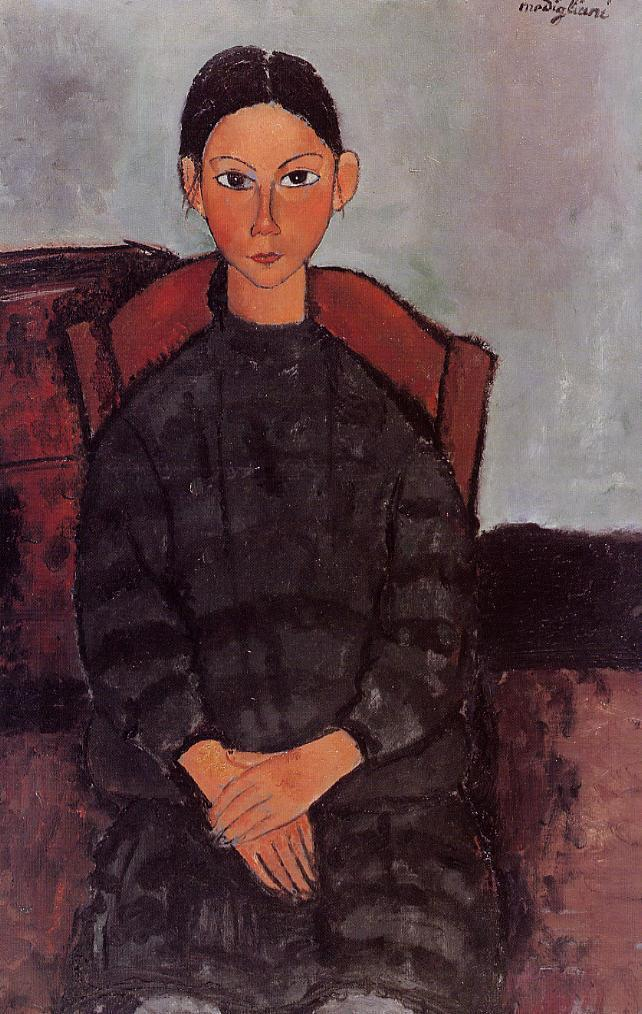Can you describe the main features of this image for me? The image portrays a woman seated in a chair, captured in the distinctive style of post-impressionism. The woman is elegantly dressed in a black dress that features a high collar, a detail that adds a touch of formality to her appearance. Her hands are gently folded in her lap, suggesting a sense of calm and composure.

The background of the image is painted in muted shades of red and brown, providing a warm contrast to the woman's black dress. On the right side of the image, there's a subtle hint of a table or desk, adding depth to the scene.

The artist's signature, "modigliani", is discreetly placed in the bottom right corner of the image, a common practice in many forms of art. This signature not only identifies the creator of the work but also adds a personal touch to the piece.

Overall, the image is a beautiful representation of portraiture, a genre that focuses on the depiction of an individual. The use of color, composition, and the subtle details all contribute to the overall impression of the woman and the setting in which she is portrayed. 